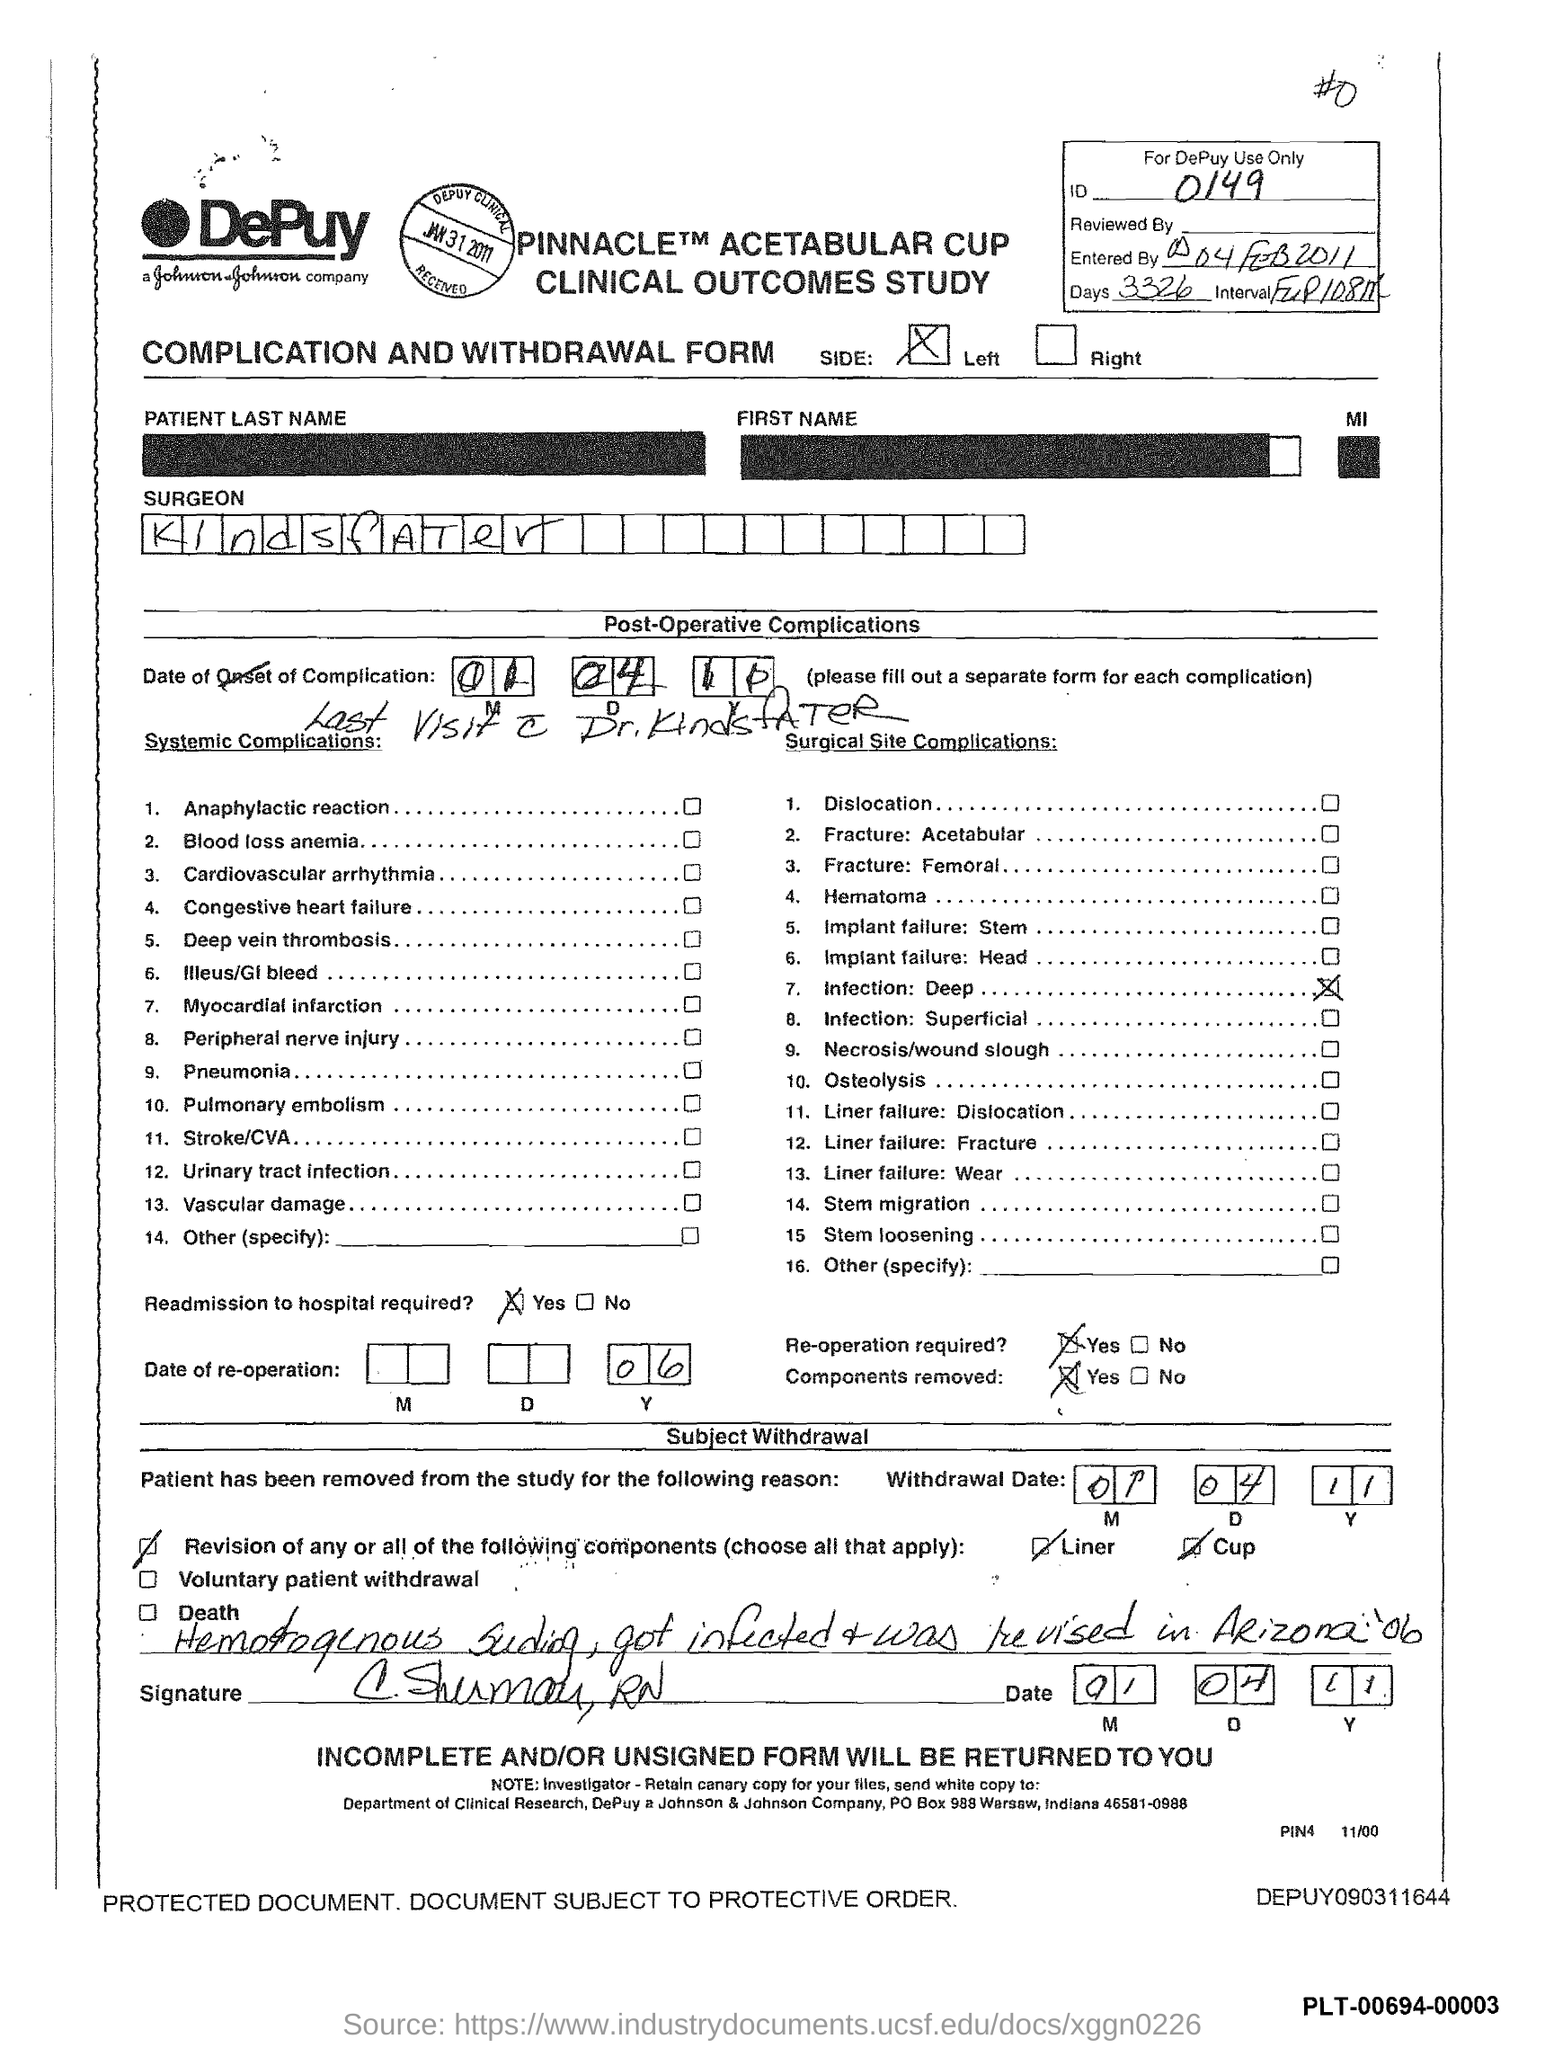Draw attention to some important aspects in this diagram. The number of days is 3326. The name of the surgeon is Kindsfater. The ID number is 0149. 